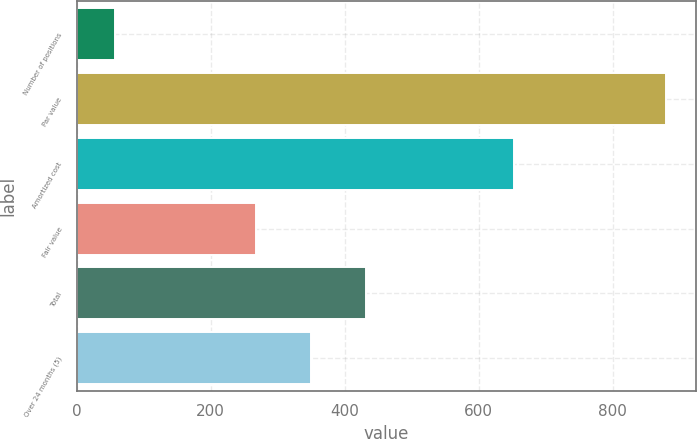Convert chart to OTSL. <chart><loc_0><loc_0><loc_500><loc_500><bar_chart><fcel>Number of positions<fcel>Par value<fcel>Amortized cost<fcel>Fair value<fcel>Total<fcel>Over 24 months (5)<nl><fcel>58<fcel>880<fcel>653<fcel>268<fcel>432.4<fcel>350.2<nl></chart> 